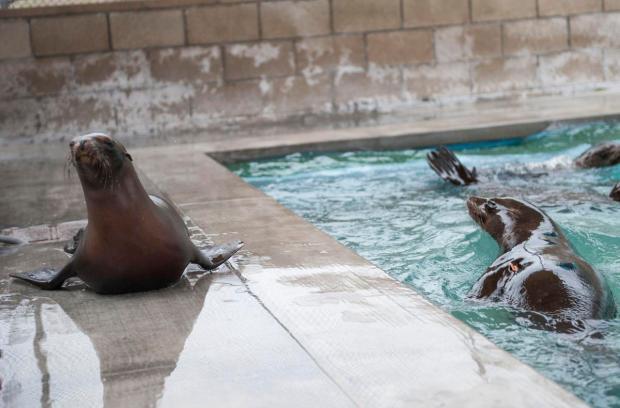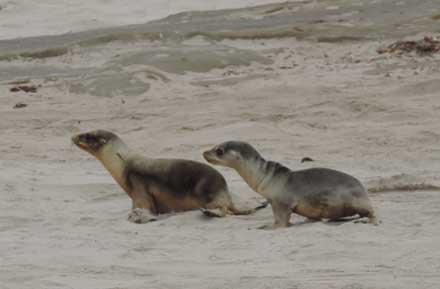The first image is the image on the left, the second image is the image on the right. For the images displayed, is the sentence "seals are swimming in a square pool with a tone wall behind them" factually correct? Answer yes or no. Yes. The first image is the image on the left, the second image is the image on the right. Given the left and right images, does the statement "In one image, there's an aquarist with at least one sea lion." hold true? Answer yes or no. No. 